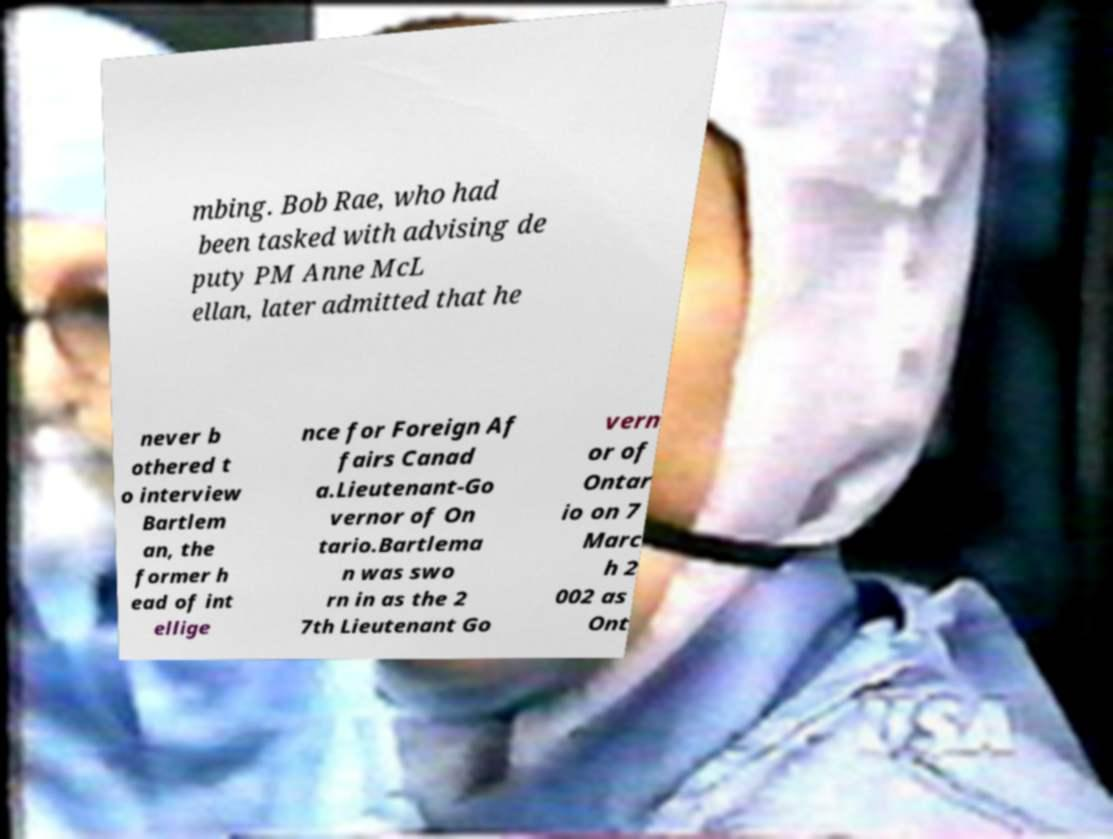Please identify and transcribe the text found in this image. mbing. Bob Rae, who had been tasked with advising de puty PM Anne McL ellan, later admitted that he never b othered t o interview Bartlem an, the former h ead of int ellige nce for Foreign Af fairs Canad a.Lieutenant-Go vernor of On tario.Bartlema n was swo rn in as the 2 7th Lieutenant Go vern or of Ontar io on 7 Marc h 2 002 as Ont 